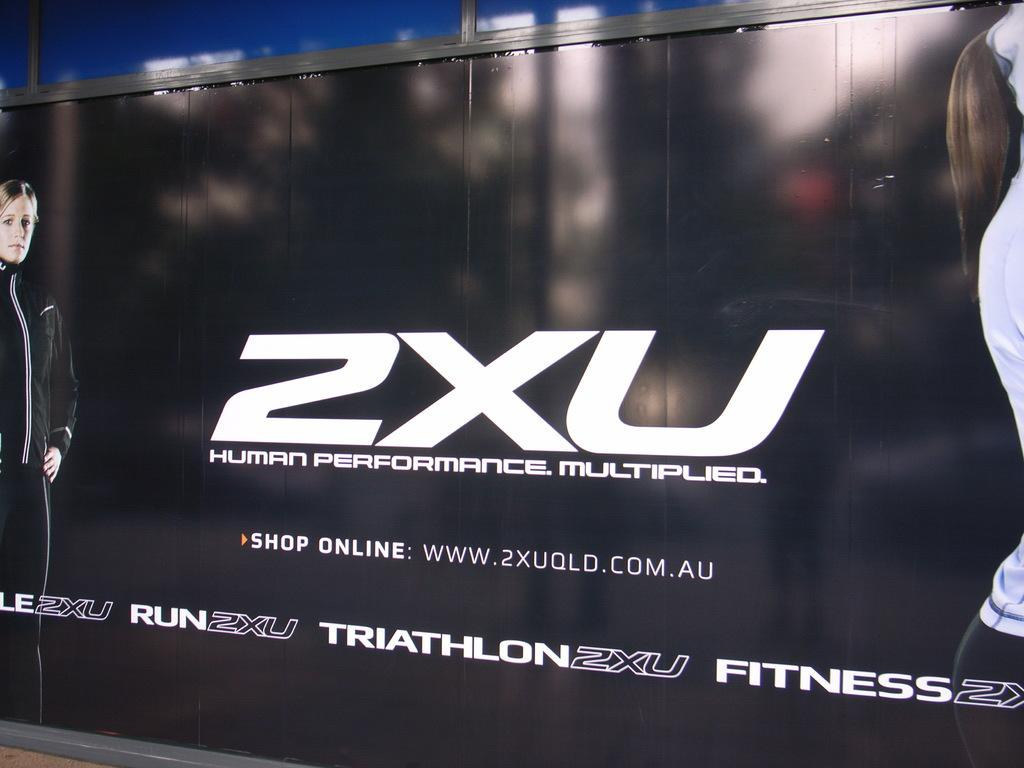<image>
Write a terse but informative summary of the picture. An online fitness ad is displayed that links to their website. 